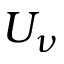<formula> <loc_0><loc_0><loc_500><loc_500>U _ { \nu }</formula> 